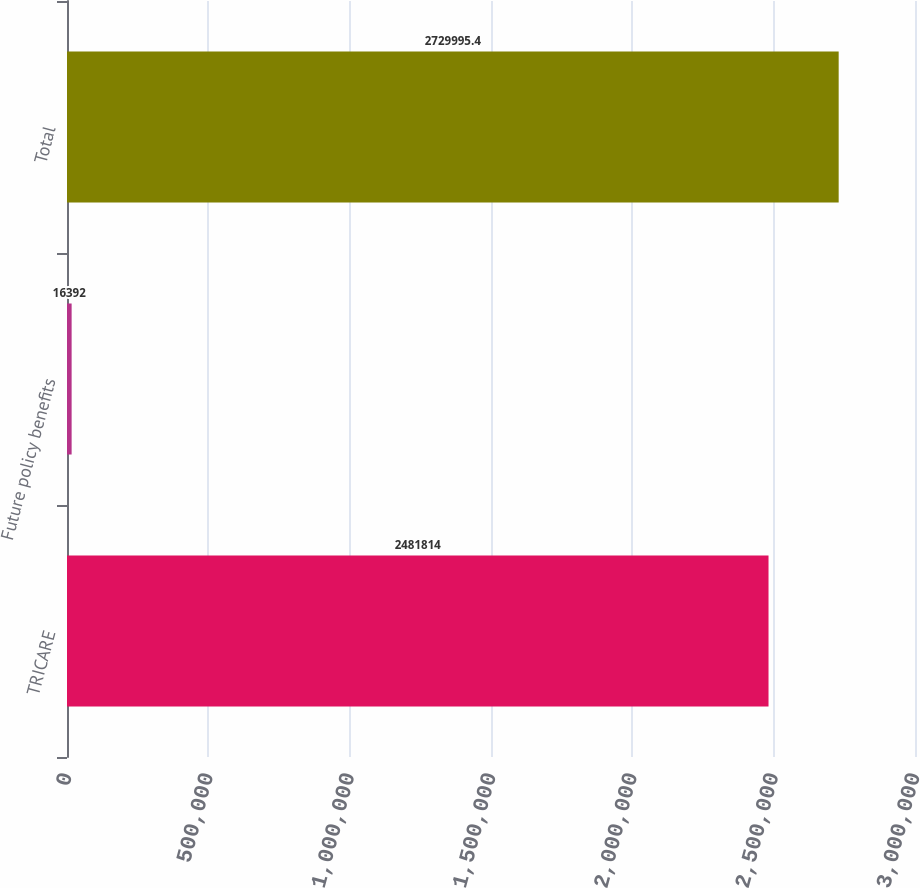Convert chart to OTSL. <chart><loc_0><loc_0><loc_500><loc_500><bar_chart><fcel>TRICARE<fcel>Future policy benefits<fcel>Total<nl><fcel>2.48181e+06<fcel>16392<fcel>2.73e+06<nl></chart> 